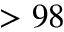<formula> <loc_0><loc_0><loc_500><loc_500>> 9 8</formula> 